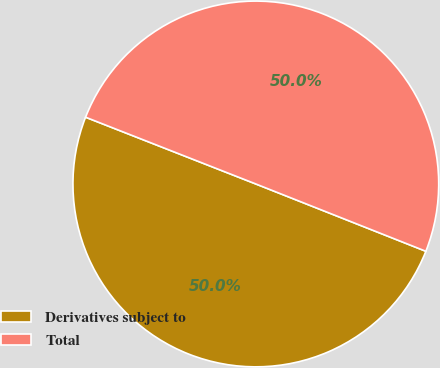Convert chart. <chart><loc_0><loc_0><loc_500><loc_500><pie_chart><fcel>Derivatives subject to<fcel>Total<nl><fcel>49.95%<fcel>50.05%<nl></chart> 